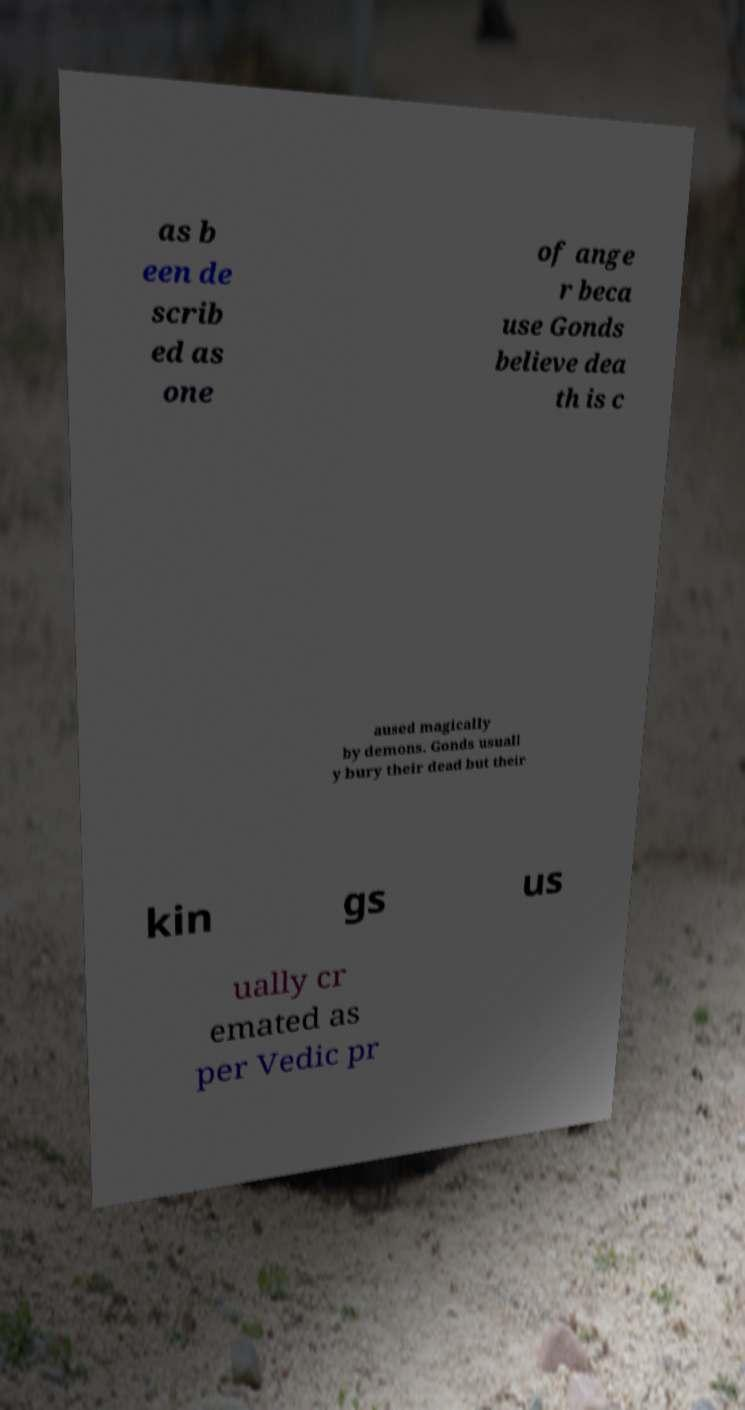What messages or text are displayed in this image? I need them in a readable, typed format. as b een de scrib ed as one of ange r beca use Gonds believe dea th is c aused magically by demons. Gonds usuall y bury their dead but their kin gs us ually cr emated as per Vedic pr 